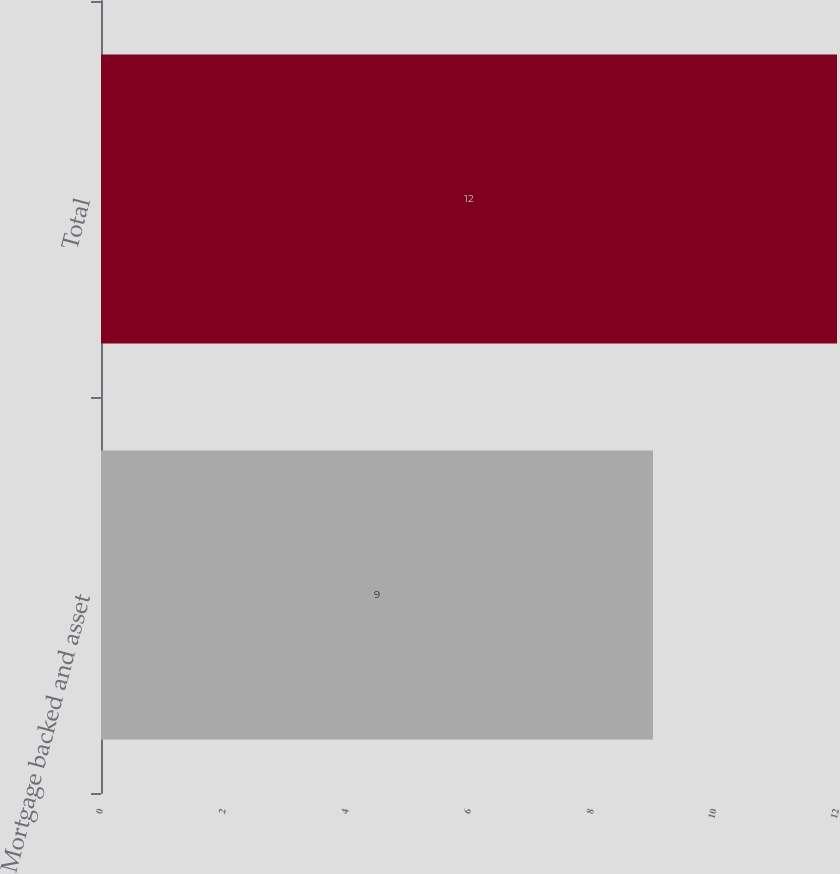Convert chart. <chart><loc_0><loc_0><loc_500><loc_500><bar_chart><fcel>Mortgage backed and asset<fcel>Total<nl><fcel>9<fcel>12<nl></chart> 